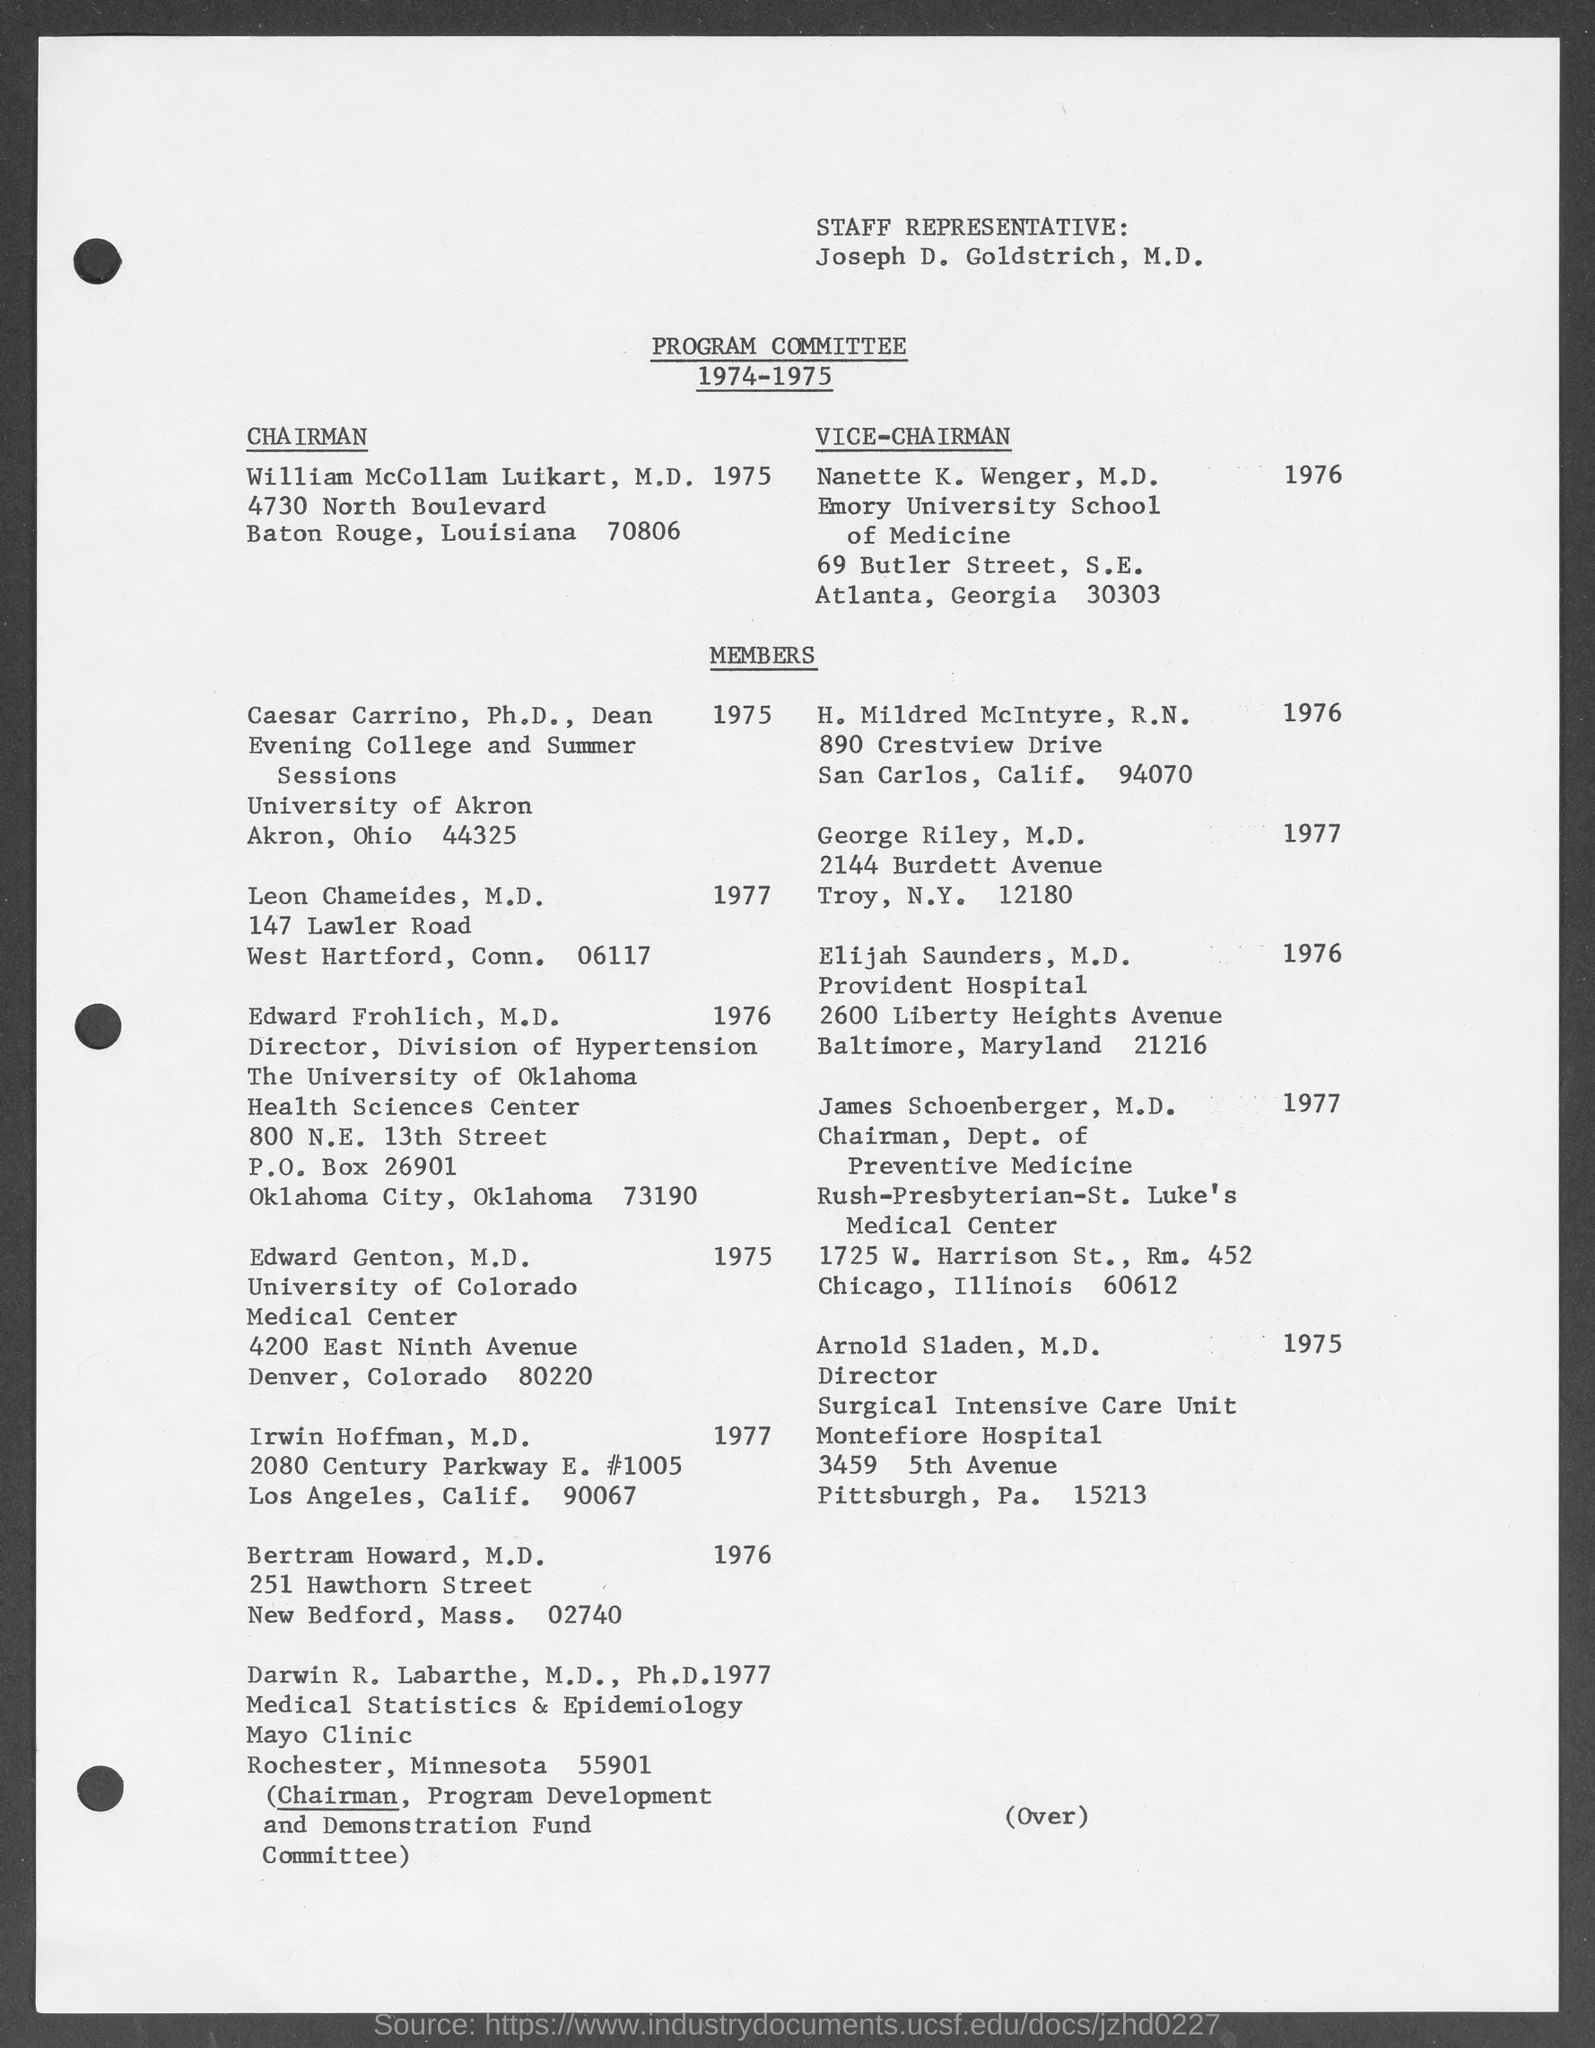To which university nanette k. wenger belongs to ?
Offer a terse response. Emory university school of medicine. To which university caesar carrino belongs to ?
Provide a succinct answer. University of akron. To which university edward frohlich belongs to ?
Offer a very short reply. The university of oklahoma. To which university edward genton belongs to ?
Make the answer very short. University of colorado. 